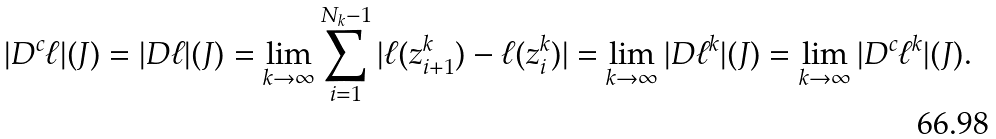<formula> <loc_0><loc_0><loc_500><loc_500>| D ^ { c } \ell | ( J ) = | D \ell | ( J ) = \lim _ { k \rightarrow \infty } \sum _ { i = 1 } ^ { N _ { k } - 1 } | \ell ( z _ { i + 1 } ^ { k } ) - \ell ( z _ { i } ^ { k } ) | = \lim _ { k \rightarrow \infty } | D \ell ^ { k } | ( J ) = \lim _ { k \rightarrow \infty } | D ^ { c } \ell ^ { k } | ( J ) .</formula> 